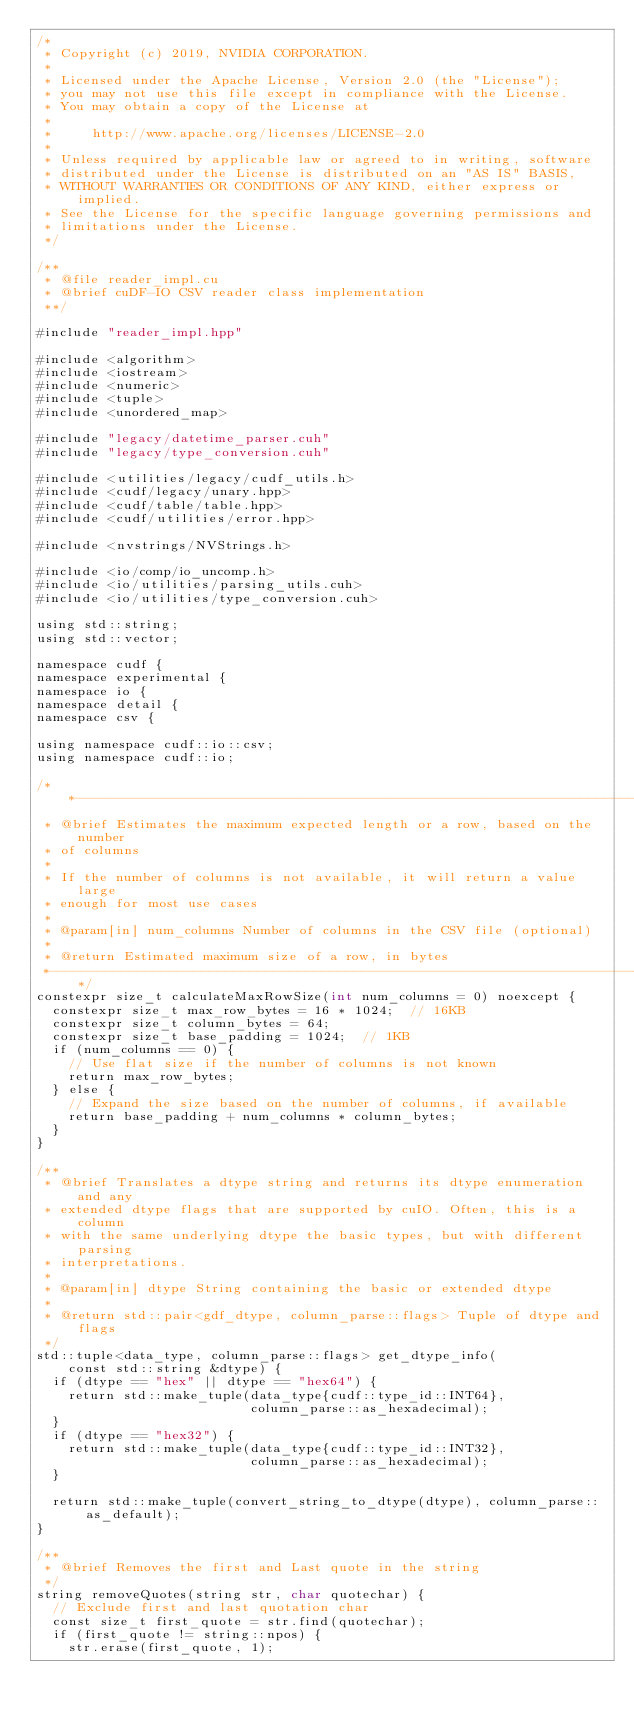<code> <loc_0><loc_0><loc_500><loc_500><_Cuda_>/*
 * Copyright (c) 2019, NVIDIA CORPORATION.
 *
 * Licensed under the Apache License, Version 2.0 (the "License");
 * you may not use this file except in compliance with the License.
 * You may obtain a copy of the License at
 *
 *     http://www.apache.org/licenses/LICENSE-2.0
 *
 * Unless required by applicable law or agreed to in writing, software
 * distributed under the License is distributed on an "AS IS" BASIS,
 * WITHOUT WARRANTIES OR CONDITIONS OF ANY KIND, either express or implied.
 * See the License for the specific language governing permissions and
 * limitations under the License.
 */

/**
 * @file reader_impl.cu
 * @brief cuDF-IO CSV reader class implementation
 **/

#include "reader_impl.hpp"

#include <algorithm>
#include <iostream>
#include <numeric>
#include <tuple>
#include <unordered_map>

#include "legacy/datetime_parser.cuh"
#include "legacy/type_conversion.cuh"

#include <utilities/legacy/cudf_utils.h>
#include <cudf/legacy/unary.hpp>
#include <cudf/table/table.hpp>
#include <cudf/utilities/error.hpp>

#include <nvstrings/NVStrings.h>

#include <io/comp/io_uncomp.h>
#include <io/utilities/parsing_utils.cuh>
#include <io/utilities/type_conversion.cuh>

using std::string;
using std::vector;

namespace cudf {
namespace experimental {
namespace io {
namespace detail {
namespace csv {

using namespace cudf::io::csv;
using namespace cudf::io;

/**---------------------------------------------------------------------------*
 * @brief Estimates the maximum expected length or a row, based on the number
 * of columns
 *
 * If the number of columns is not available, it will return a value large
 * enough for most use cases
 *
 * @param[in] num_columns Number of columns in the CSV file (optional)
 *
 * @return Estimated maximum size of a row, in bytes
 *---------------------------------------------------------------------------**/
constexpr size_t calculateMaxRowSize(int num_columns = 0) noexcept {
  constexpr size_t max_row_bytes = 16 * 1024;  // 16KB
  constexpr size_t column_bytes = 64;
  constexpr size_t base_padding = 1024;  // 1KB
  if (num_columns == 0) {
    // Use flat size if the number of columns is not known
    return max_row_bytes;
  } else {
    // Expand the size based on the number of columns, if available
    return base_padding + num_columns * column_bytes;
  }
}

/**
 * @brief Translates a dtype string and returns its dtype enumeration and any
 * extended dtype flags that are supported by cuIO. Often, this is a column
 * with the same underlying dtype the basic types, but with different parsing
 * interpretations.
 *
 * @param[in] dtype String containing the basic or extended dtype
 *
 * @return std::pair<gdf_dtype, column_parse::flags> Tuple of dtype and flags
 */
std::tuple<data_type, column_parse::flags> get_dtype_info(
    const std::string &dtype) {
  if (dtype == "hex" || dtype == "hex64") {
    return std::make_tuple(data_type{cudf::type_id::INT64},
                           column_parse::as_hexadecimal);
  }
  if (dtype == "hex32") {
    return std::make_tuple(data_type{cudf::type_id::INT32},
                           column_parse::as_hexadecimal);
  }

  return std::make_tuple(convert_string_to_dtype(dtype), column_parse::as_default);
}

/**
 * @brief Removes the first and Last quote in the string
 */
string removeQuotes(string str, char quotechar) {
  // Exclude first and last quotation char
  const size_t first_quote = str.find(quotechar);
  if (first_quote != string::npos) {
    str.erase(first_quote, 1);</code> 